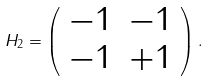Convert formula to latex. <formula><loc_0><loc_0><loc_500><loc_500>H _ { 2 } = \left ( \begin{array} { c c } - 1 & - 1 \\ - 1 & + 1 \end{array} \right ) .</formula> 